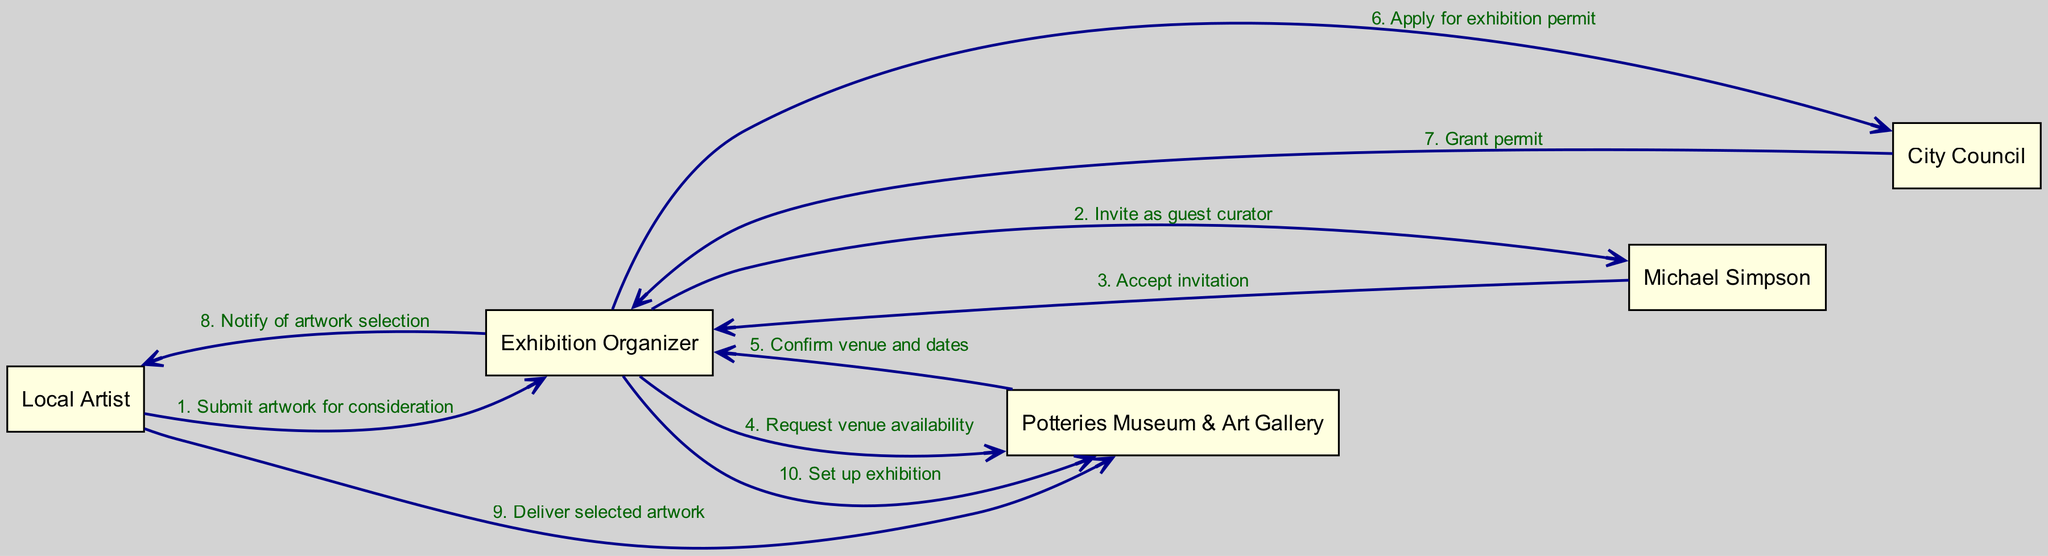What is the first interaction in the sequence? The first interaction is between the Local Artist and the Exhibition Organizer, where the Local Artist submits artwork for consideration. This is the first message listed in the sequence.
Answer: Submit artwork for consideration Who is invited as a guest curator? The Exhibition Organizer invites Michael Simpson as the guest curator, as indicated by the second interaction in the sequence.
Answer: Michael Simpson How many actors are involved in the sequence? There are five distinct actors involved in the sequence, as listed at the beginning of the diagram: Local Artist, Exhibition Organizer, Potteries Museum & Art Gallery, Michael Simpson, and City Council.
Answer: 5 In which step does the City Council grant the permit? The City Council grants the exhibition permit after the Exhibition Organizer applies for it, which is documented as the sixth interaction followed by the seventh where the permit is granted.
Answer: Step 7 What action follows the confirmation of venue and dates? After the Potteries Museum & Art Gallery confirms the venue and dates, the next action is for the Exhibition Organizer to apply for an exhibition permit, which is the sixth interaction in the sequence.
Answer: Apply for exhibition permit Which actor delivers the selected artwork? The Local Artist is responsible for delivering the selected artwork to the Potteries Museum & Art Gallery, as detailed in the ninth interaction of the sequence.
Answer: Local Artist What is the final action in the sequence? The final action in the sequence is for the Exhibition Organizer to set up the exhibition at the Potteries Museum & Art Gallery, which is indicated as the last interaction in the diagram.
Answer: Set up exhibition 